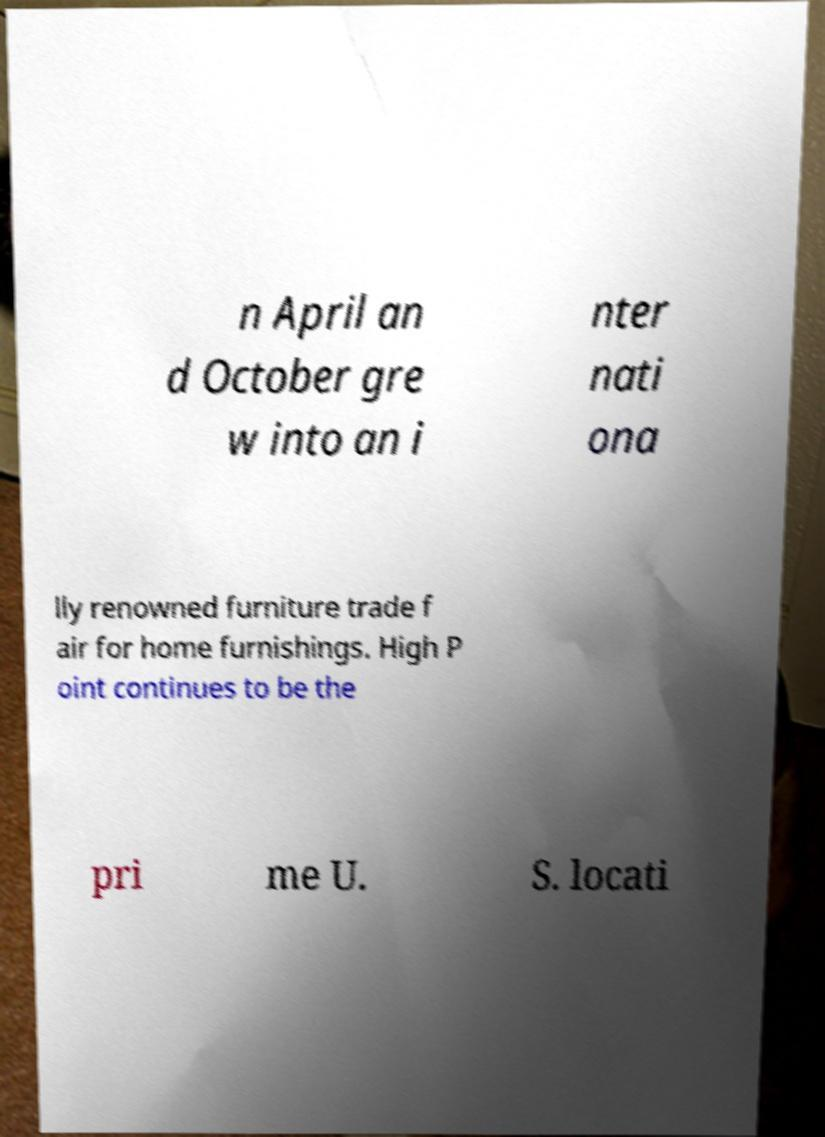Can you read and provide the text displayed in the image?This photo seems to have some interesting text. Can you extract and type it out for me? n April an d October gre w into an i nter nati ona lly renowned furniture trade f air for home furnishings. High P oint continues to be the pri me U. S. locati 